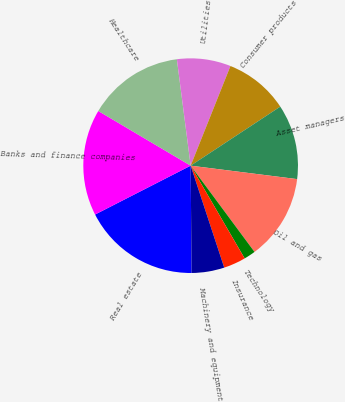Convert chart. <chart><loc_0><loc_0><loc_500><loc_500><pie_chart><fcel>Real estate<fcel>Banks and finance companies<fcel>Healthcare<fcel>Utilities<fcel>Consumer products<fcel>Asset managers<fcel>Oil and gas<fcel>Technology<fcel>Insurance<fcel>Machinery and equipment<nl><fcel>17.62%<fcel>16.03%<fcel>14.44%<fcel>8.1%<fcel>9.68%<fcel>11.27%<fcel>12.86%<fcel>1.75%<fcel>3.33%<fcel>4.92%<nl></chart> 